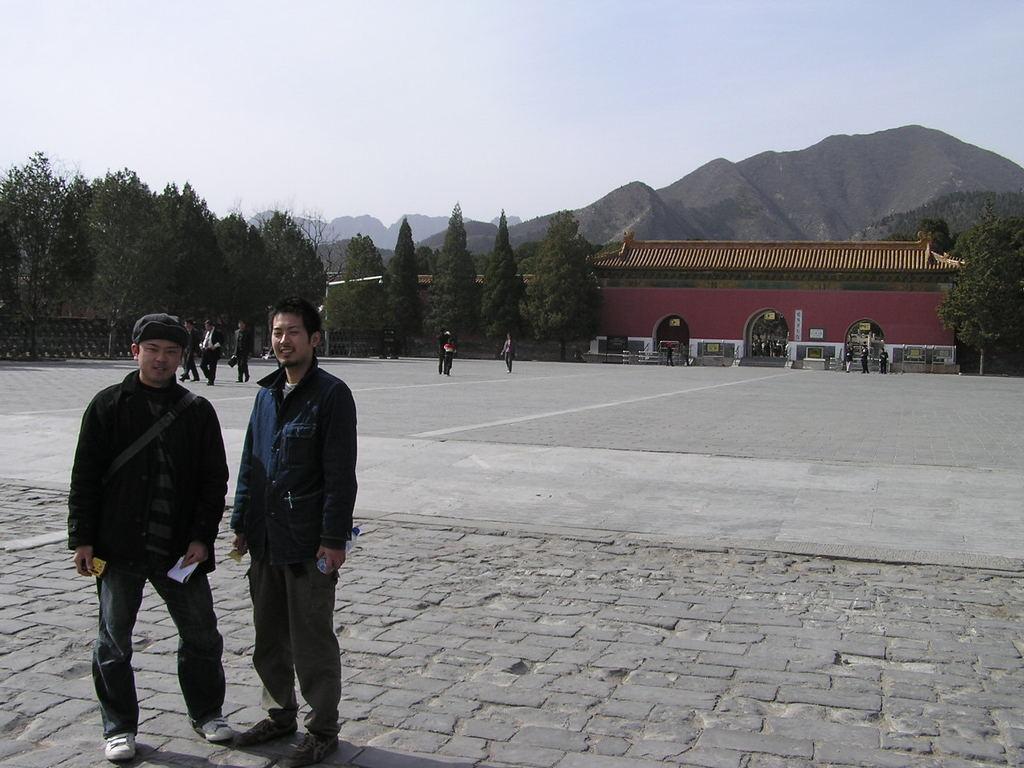Could you give a brief overview of what you see in this image? In this image in the foreground there are two people standing, and they are holding some papers. And in the background there are buildings, trees and some people and at the bottom there is walkway and there are mountains in the background. At the top there is sky. 